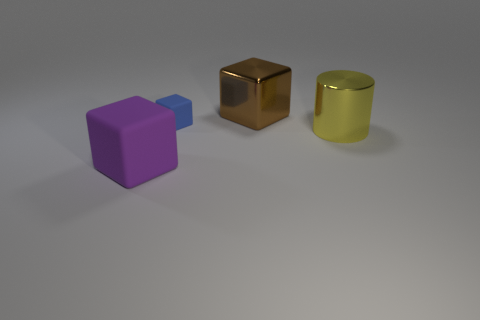Can you tell me what shapes are visible in this image? Certainly! There are three distinct shapes present: a purple cube on the left, a brownish-gold cube in the center, and a gold cylindrical object on the right. What could be the context or use of these objects? These objects resemble minimalist 3D models, possibly intended for a graphical rendering test or an abstract art piece. Their use could range from visual effects templates to educational demonstrations about shapes and light in a computer-generated environment. 